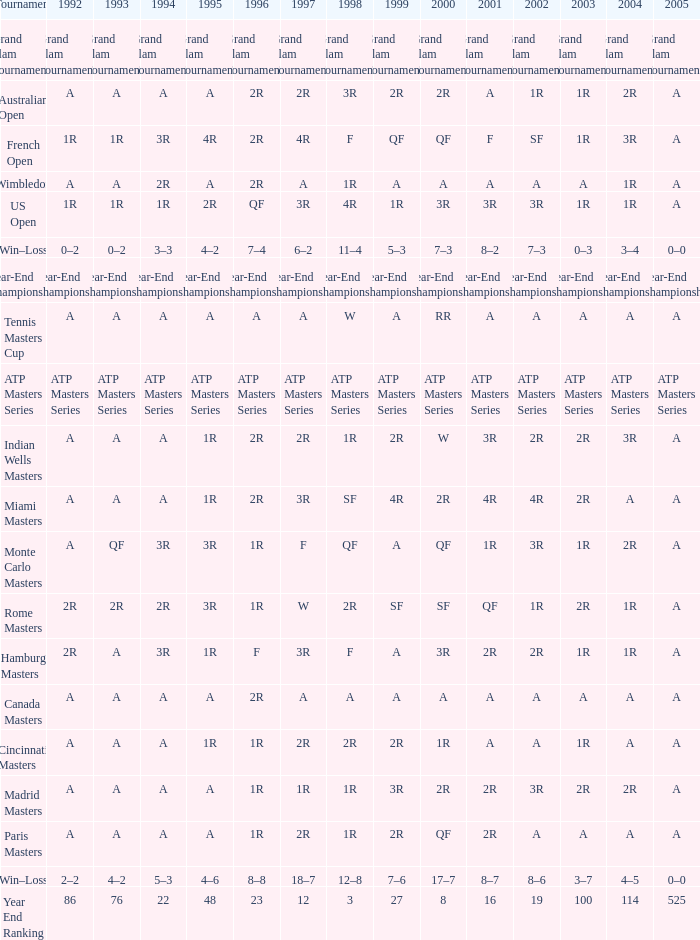What is 2005, when 1998 is "F", and when 2002 is "2R"? A. 